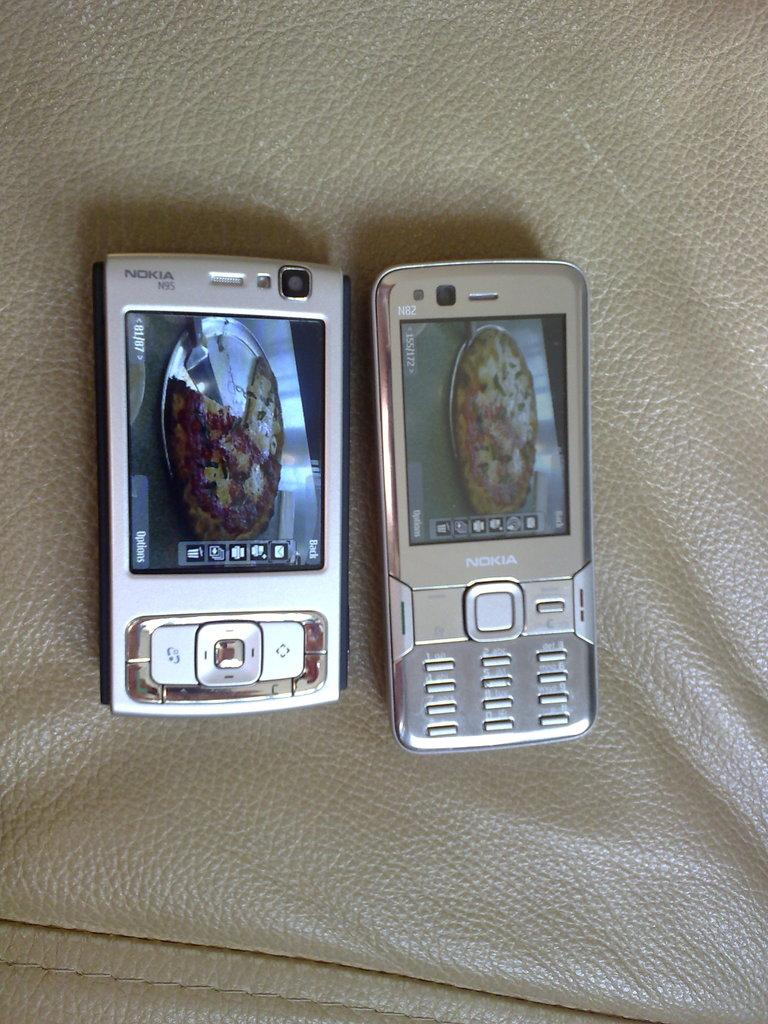What electronic devices are present in the image? There are two mobile phones in the image. What feature do the mobile phones have? The mobile phones have buttons. Where are the mobile phones placed in the image? The mobile phones are placed on a leather mat. Can you describe the leather mat in the image? The leather mat has stitching. What type of quill is being used to write on the leather mat in the image? There is no quill present in the image; the mobile phones and their buttons are the main focus. 